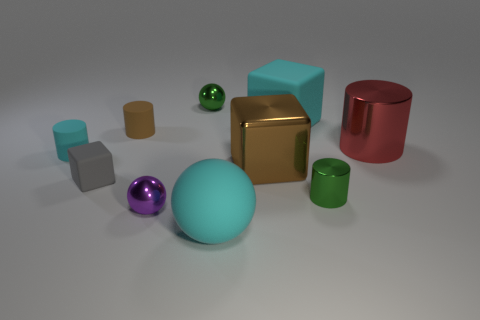Subtract all rubber spheres. How many spheres are left? 2 Subtract 3 cylinders. How many cylinders are left? 1 Subtract all cyan blocks. How many blocks are left? 2 Subtract all cylinders. How many objects are left? 6 Subtract all purple cubes. Subtract all red cylinders. How many cubes are left? 3 Subtract all red balls. How many yellow blocks are left? 0 Subtract all big red metal cylinders. Subtract all tiny yellow rubber blocks. How many objects are left? 9 Add 8 metal cubes. How many metal cubes are left? 9 Add 9 cyan cylinders. How many cyan cylinders exist? 10 Subtract 0 red balls. How many objects are left? 10 